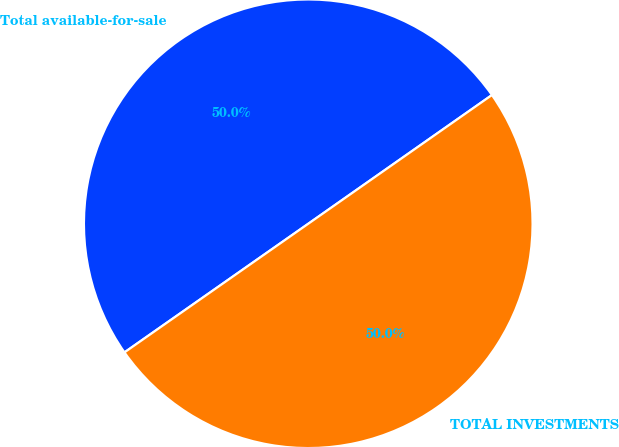Convert chart to OTSL. <chart><loc_0><loc_0><loc_500><loc_500><pie_chart><fcel>Total available-for-sale<fcel>TOTAL INVESTMENTS<nl><fcel>49.99%<fcel>50.01%<nl></chart> 